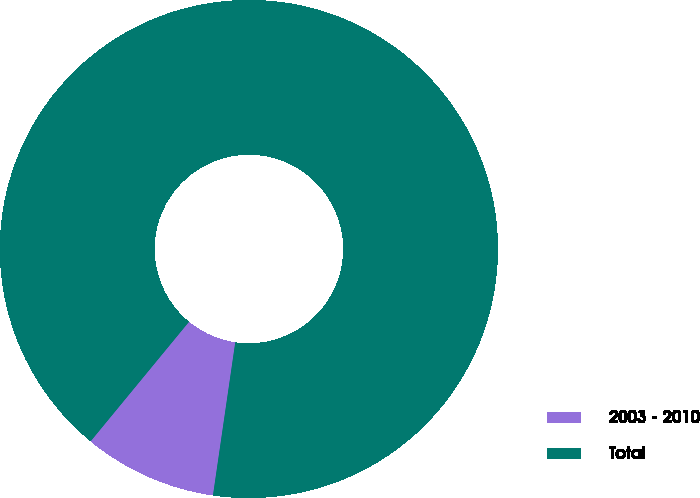Convert chart to OTSL. <chart><loc_0><loc_0><loc_500><loc_500><pie_chart><fcel>2003 - 2010<fcel>Total<nl><fcel>8.66%<fcel>91.34%<nl></chart> 